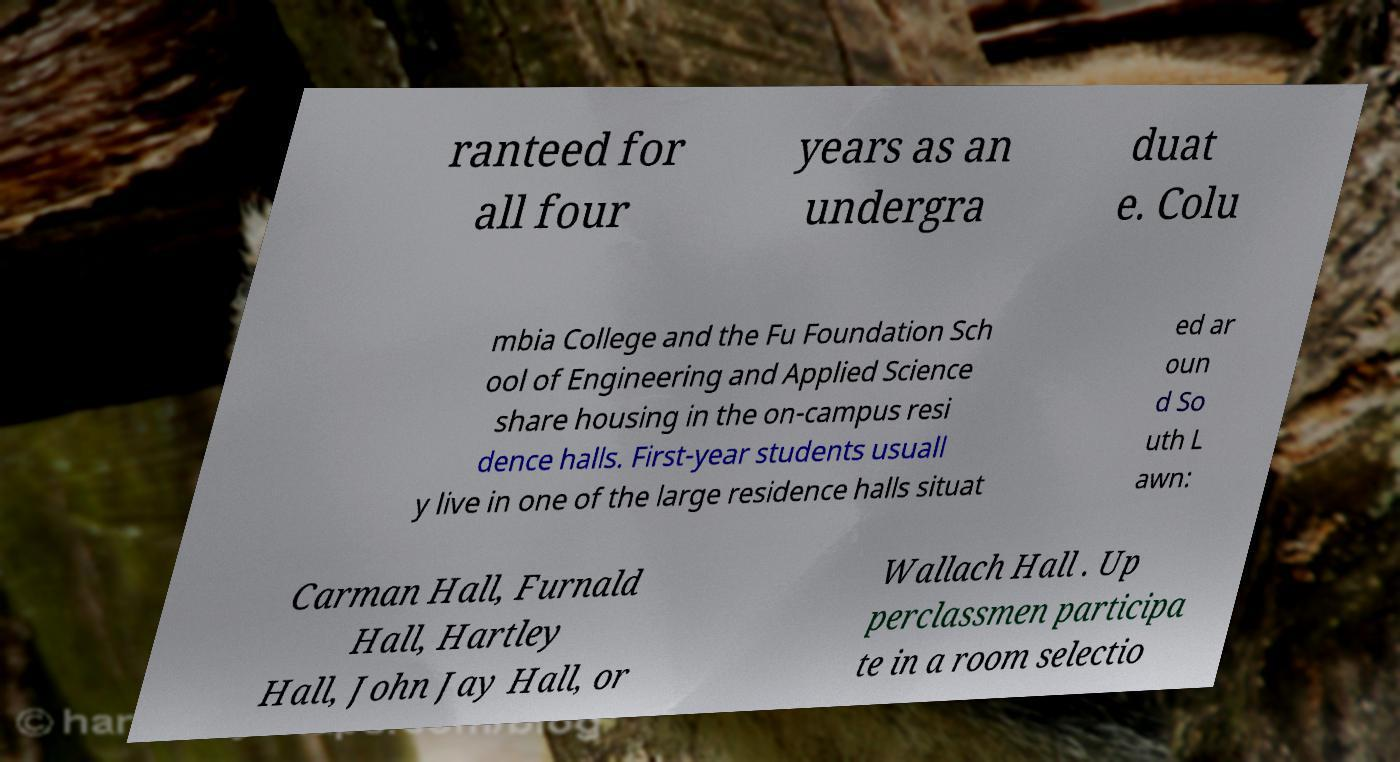There's text embedded in this image that I need extracted. Can you transcribe it verbatim? ranteed for all four years as an undergra duat e. Colu mbia College and the Fu Foundation Sch ool of Engineering and Applied Science share housing in the on-campus resi dence halls. First-year students usuall y live in one of the large residence halls situat ed ar oun d So uth L awn: Carman Hall, Furnald Hall, Hartley Hall, John Jay Hall, or Wallach Hall . Up perclassmen participa te in a room selectio 